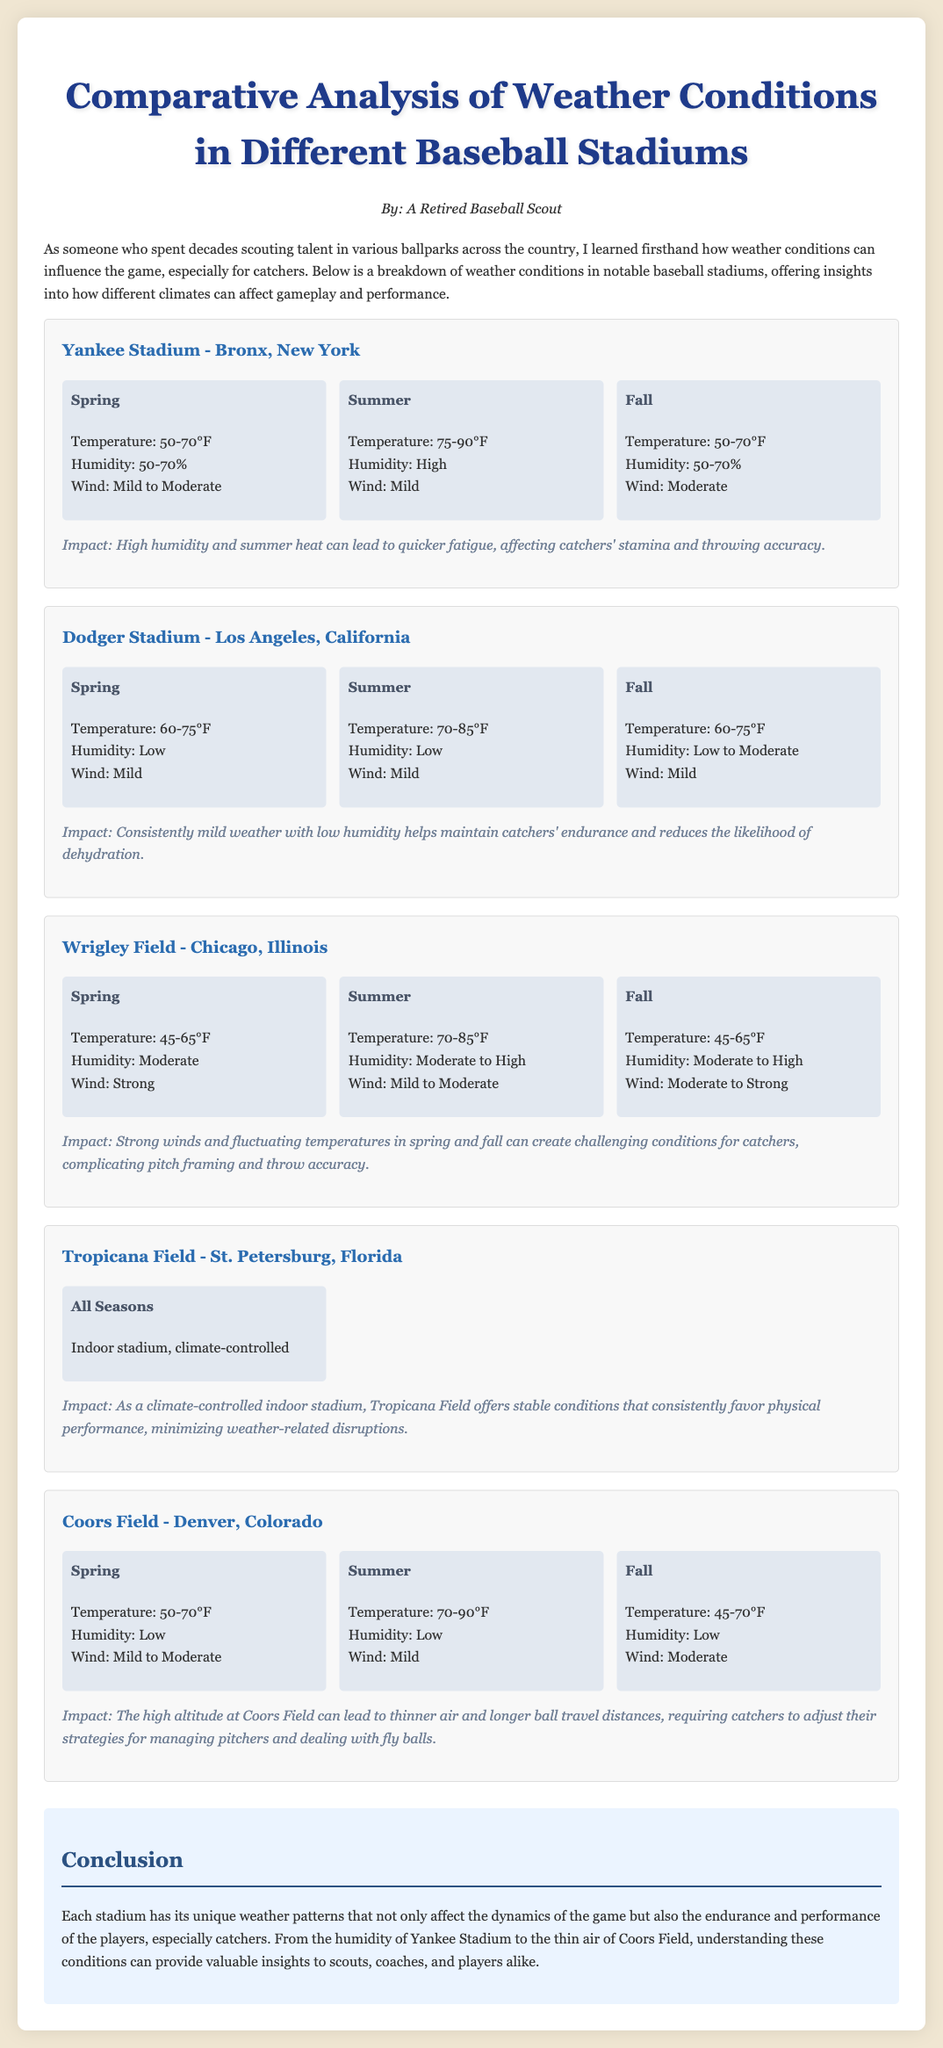What is the temperature range during Spring at Yankee Stadium? The temperature range during Spring at Yankee Stadium is specified as 50-70°F.
Answer: 50-70°F What humidity level is reported for Summer at Dodger Stadium? The humidity level reported for Summer at Dodger Stadium is low.
Answer: Low What impact does high humidity and summer heat have on catchers at Yankee Stadium? The impact noted is that high humidity and summer heat can lead to quicker fatigue, affecting catchers' stamina and throwing accuracy.
Answer: Quicker fatigue Which stadium provides climate-controlled conditions year-round? The stadium that provides climate-controlled conditions year-round is Tropicana Field.
Answer: Tropicana Field What weather condition primarily affects catchers at Wrigley Field during Spring? The primary weather condition affecting catchers at Wrigley Field during Spring is strong winds.
Answer: Strong winds What is the typical temperature range in Fall at Coors Field? The typical temperature range in Fall at Coors Field is stated as 45-70°F.
Answer: 45-70°F How does the weather at Coors Field affect fly balls? The document mentions that the high altitude can lead to thinner air and longer ball travel distances, requiring catchers to adjust their strategies.
Answer: Longer ball travel distances What is the humidity level during Spring at Wrigley Field? The humidity level during Spring at Wrigley Field is moderate.
Answer: Moderate 